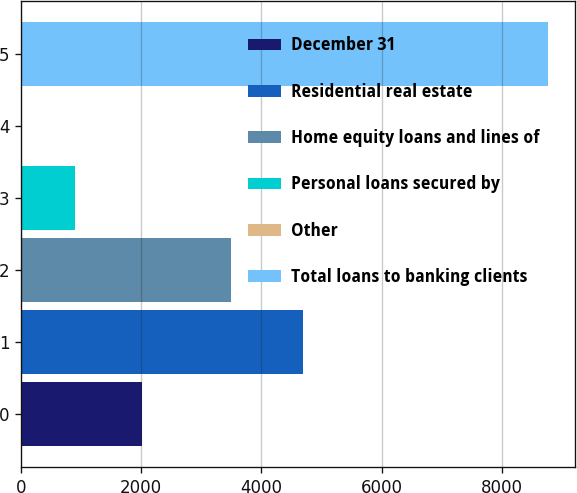Convert chart to OTSL. <chart><loc_0><loc_0><loc_500><loc_500><bar_chart><fcel>December 31<fcel>Residential real estate<fcel>Home equity loans and lines of<fcel>Personal loans secured by<fcel>Other<fcel>Total loans to banking clients<nl><fcel>2010<fcel>4695<fcel>3500<fcel>891.7<fcel>16<fcel>8773<nl></chart> 